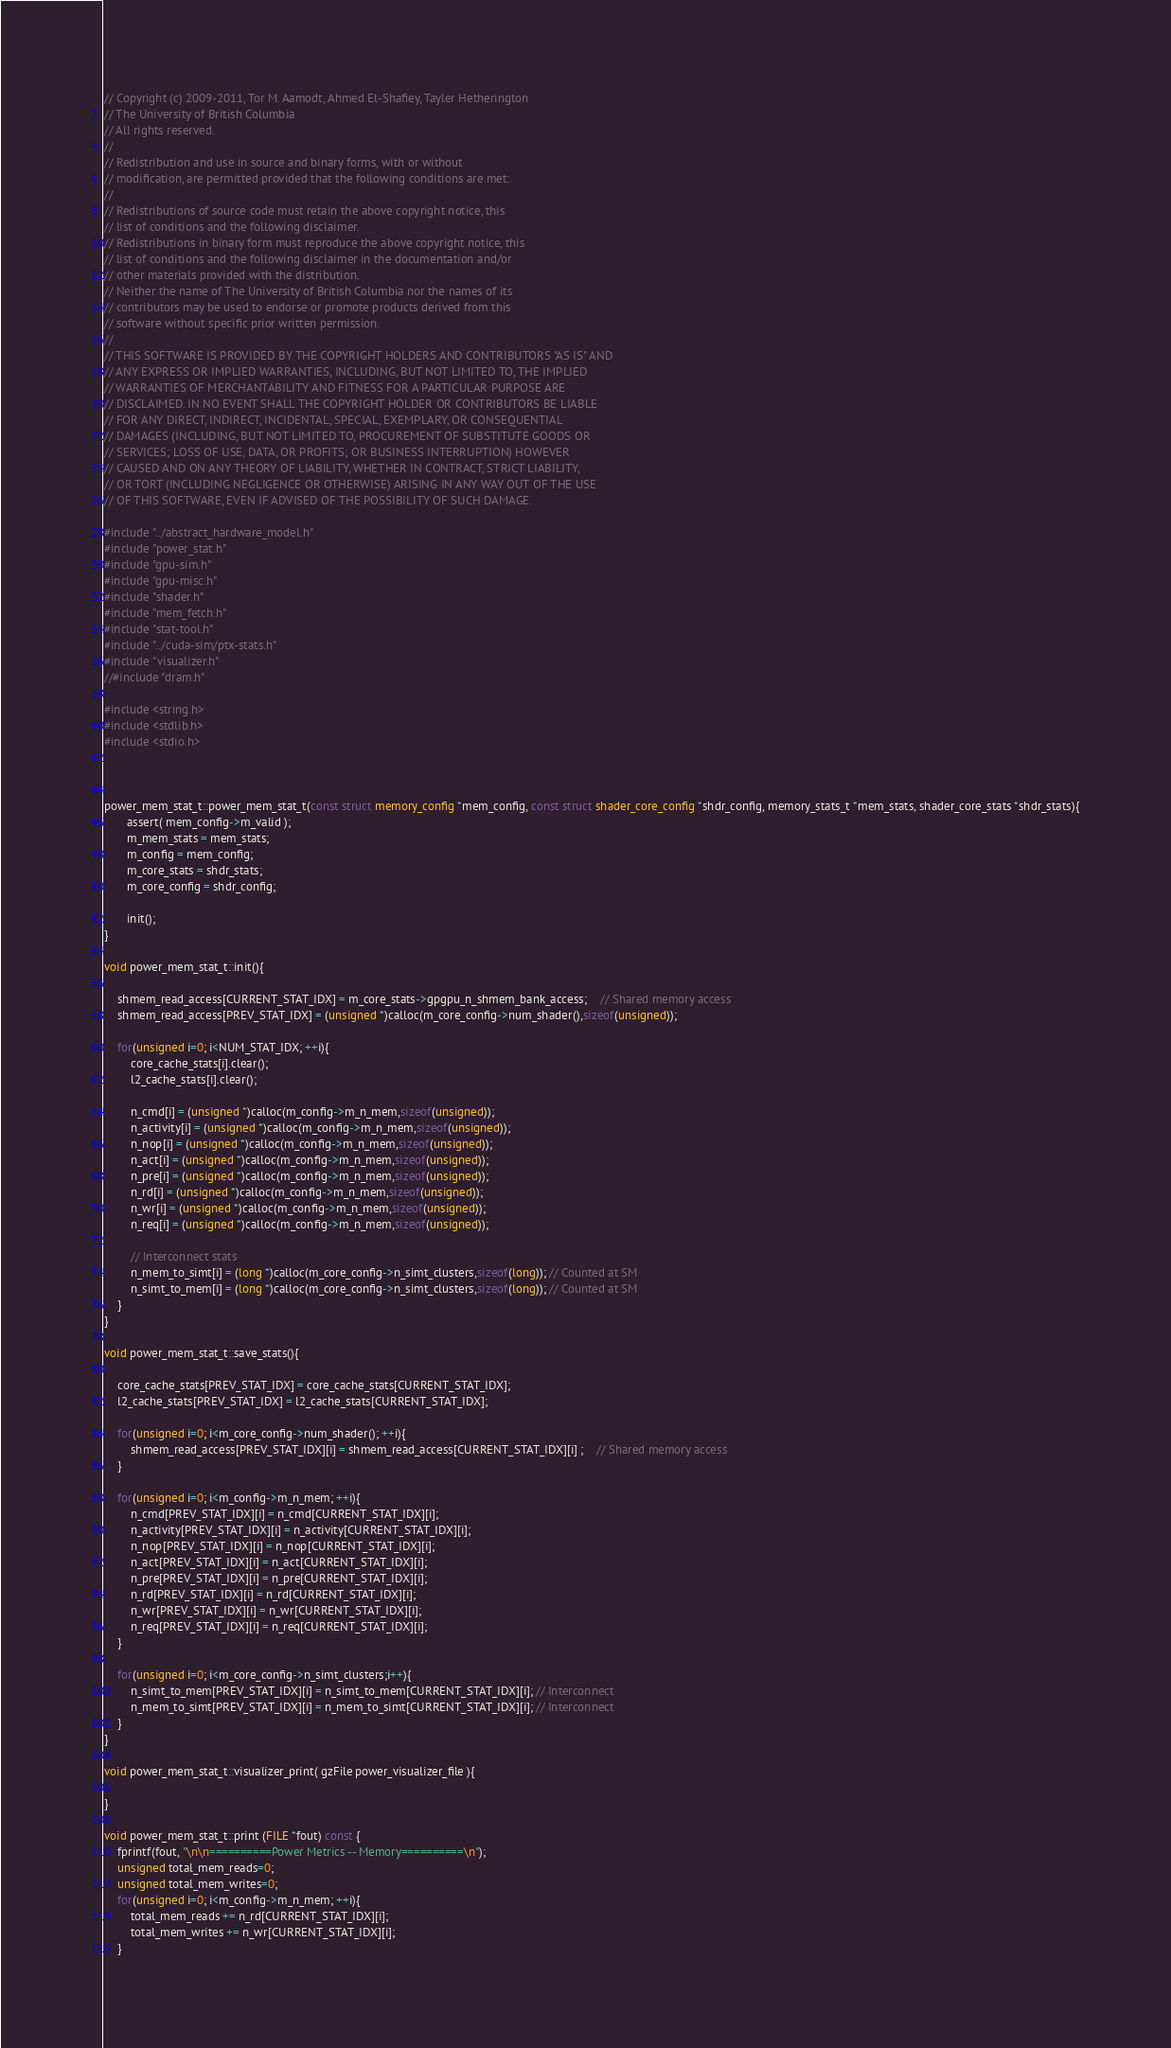Convert code to text. <code><loc_0><loc_0><loc_500><loc_500><_C++_>// Copyright (c) 2009-2011, Tor M. Aamodt, Ahmed El-Shafiey, Tayler Hetherington
// The University of British Columbia
// All rights reserved.
//
// Redistribution and use in source and binary forms, with or without
// modification, are permitted provided that the following conditions are met:
//
// Redistributions of source code must retain the above copyright notice, this
// list of conditions and the following disclaimer.
// Redistributions in binary form must reproduce the above copyright notice, this
// list of conditions and the following disclaimer in the documentation and/or
// other materials provided with the distribution.
// Neither the name of The University of British Columbia nor the names of its
// contributors may be used to endorse or promote products derived from this
// software without specific prior written permission.
//
// THIS SOFTWARE IS PROVIDED BY THE COPYRIGHT HOLDERS AND CONTRIBUTORS "AS IS" AND
// ANY EXPRESS OR IMPLIED WARRANTIES, INCLUDING, BUT NOT LIMITED TO, THE IMPLIED
// WARRANTIES OF MERCHANTABILITY AND FITNESS FOR A PARTICULAR PURPOSE ARE
// DISCLAIMED. IN NO EVENT SHALL THE COPYRIGHT HOLDER OR CONTRIBUTORS BE LIABLE
// FOR ANY DIRECT, INDIRECT, INCIDENTAL, SPECIAL, EXEMPLARY, OR CONSEQUENTIAL
// DAMAGES (INCLUDING, BUT NOT LIMITED TO, PROCUREMENT OF SUBSTITUTE GOODS OR
// SERVICES; LOSS OF USE, DATA, OR PROFITS; OR BUSINESS INTERRUPTION) HOWEVER
// CAUSED AND ON ANY THEORY OF LIABILITY, WHETHER IN CONTRACT, STRICT LIABILITY,
// OR TORT (INCLUDING NEGLIGENCE OR OTHERWISE) ARISING IN ANY WAY OUT OF THE USE
// OF THIS SOFTWARE, EVEN IF ADVISED OF THE POSSIBILITY OF SUCH DAMAGE.

#include "../abstract_hardware_model.h"
#include "power_stat.h"
#include "gpu-sim.h"
#include "gpu-misc.h"
#include "shader.h"
#include "mem_fetch.h"
#include "stat-tool.h"
#include "../cuda-sim/ptx-stats.h"
#include "visualizer.h"
//#include "dram.h"

#include <string.h>
#include <stdlib.h>
#include <stdio.h>



power_mem_stat_t::power_mem_stat_t(const struct memory_config *mem_config, const struct shader_core_config *shdr_config, memory_stats_t *mem_stats, shader_core_stats *shdr_stats){
	   assert( mem_config->m_valid );
	   m_mem_stats = mem_stats;
	   m_config = mem_config;
	   m_core_stats = shdr_stats;
	   m_core_config = shdr_config;

	   init();
}

void power_mem_stat_t::init(){

    shmem_read_access[CURRENT_STAT_IDX] = m_core_stats->gpgpu_n_shmem_bank_access; 	// Shared memory access
    shmem_read_access[PREV_STAT_IDX] = (unsigned *)calloc(m_core_config->num_shader(),sizeof(unsigned));

    for(unsigned i=0; i<NUM_STAT_IDX; ++i){
        core_cache_stats[i].clear();
        l2_cache_stats[i].clear();

        n_cmd[i] = (unsigned *)calloc(m_config->m_n_mem,sizeof(unsigned));
        n_activity[i] = (unsigned *)calloc(m_config->m_n_mem,sizeof(unsigned));
        n_nop[i] = (unsigned *)calloc(m_config->m_n_mem,sizeof(unsigned));
        n_act[i] = (unsigned *)calloc(m_config->m_n_mem,sizeof(unsigned));
        n_pre[i] = (unsigned *)calloc(m_config->m_n_mem,sizeof(unsigned));
        n_rd[i] = (unsigned *)calloc(m_config->m_n_mem,sizeof(unsigned));
        n_wr[i] = (unsigned *)calloc(m_config->m_n_mem,sizeof(unsigned));
        n_req[i] = (unsigned *)calloc(m_config->m_n_mem,sizeof(unsigned));

        // Interconnect stats
        n_mem_to_simt[i] = (long *)calloc(m_core_config->n_simt_clusters,sizeof(long)); // Counted at SM
        n_simt_to_mem[i] = (long *)calloc(m_core_config->n_simt_clusters,sizeof(long)); // Counted at SM
    }
}

void power_mem_stat_t::save_stats(){

    core_cache_stats[PREV_STAT_IDX] = core_cache_stats[CURRENT_STAT_IDX];
    l2_cache_stats[PREV_STAT_IDX] = l2_cache_stats[CURRENT_STAT_IDX];

    for(unsigned i=0; i<m_core_config->num_shader(); ++i){
        shmem_read_access[PREV_STAT_IDX][i] = shmem_read_access[CURRENT_STAT_IDX][i] ; 	// Shared memory access
    }

    for(unsigned i=0; i<m_config->m_n_mem; ++i){
        n_cmd[PREV_STAT_IDX][i] = n_cmd[CURRENT_STAT_IDX][i];
        n_activity[PREV_STAT_IDX][i] = n_activity[CURRENT_STAT_IDX][i];
        n_nop[PREV_STAT_IDX][i] = n_nop[CURRENT_STAT_IDX][i];
        n_act[PREV_STAT_IDX][i] = n_act[CURRENT_STAT_IDX][i];
        n_pre[PREV_STAT_IDX][i] = n_pre[CURRENT_STAT_IDX][i];
        n_rd[PREV_STAT_IDX][i] = n_rd[CURRENT_STAT_IDX][i];
        n_wr[PREV_STAT_IDX][i] = n_wr[CURRENT_STAT_IDX][i];
        n_req[PREV_STAT_IDX][i] = n_req[CURRENT_STAT_IDX][i];
    }

    for(unsigned i=0; i<m_core_config->n_simt_clusters;i++){
        n_simt_to_mem[PREV_STAT_IDX][i] = n_simt_to_mem[CURRENT_STAT_IDX][i]; // Interconnect
        n_mem_to_simt[PREV_STAT_IDX][i] = n_mem_to_simt[CURRENT_STAT_IDX][i]; // Interconnect
    }
}

void power_mem_stat_t::visualizer_print( gzFile power_visualizer_file ){

}

void power_mem_stat_t::print (FILE *fout) const {
	fprintf(fout, "\n\n==========Power Metrics -- Memory==========\n");
    unsigned total_mem_reads=0;
    unsigned total_mem_writes=0;
    for(unsigned i=0; i<m_config->m_n_mem; ++i){
        total_mem_reads += n_rd[CURRENT_STAT_IDX][i];
        total_mem_writes += n_wr[CURRENT_STAT_IDX][i];
    }</code> 